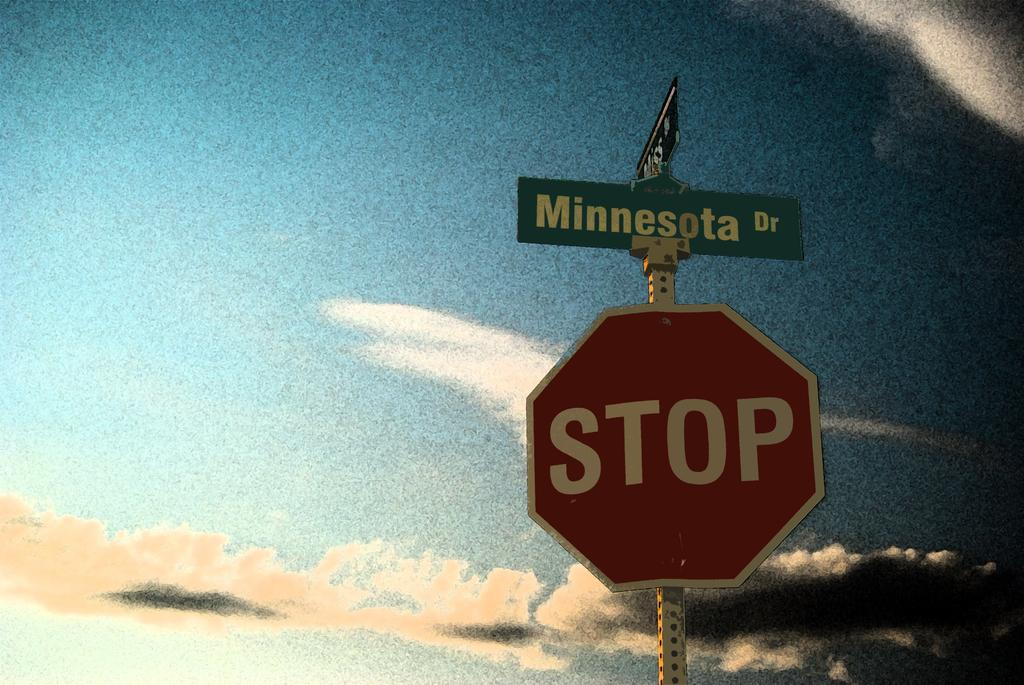<image>
Describe the image concisely. A red stop sign has a green street sign above it that says Minnesota Dr. 